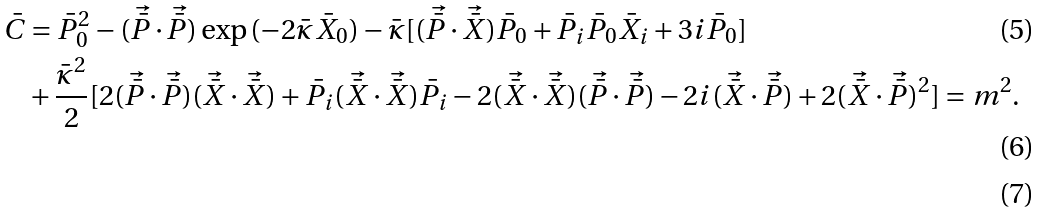Convert formula to latex. <formula><loc_0><loc_0><loc_500><loc_500>\bar { C } & = \bar { P } _ { 0 } ^ { 2 } - ( \vec { \bar { P } } \cdot \vec { \bar { P } } ) \exp { ( - 2 \bar { \kappa } \bar { X } _ { 0 } ) } - \bar { \kappa } [ ( \vec { \bar { P } } \cdot \vec { \bar { X } } ) \bar { P } _ { 0 } + \bar { P } _ { i } \bar { P } _ { 0 } \bar { X } _ { i } + 3 i \bar { P } _ { 0 } ] \\ & + \frac { \bar { \kappa } ^ { 2 } } { 2 } [ 2 ( \vec { \bar { P } } \cdot \vec { \bar { P } } ) ( \vec { \bar { X } } \cdot \vec { \bar { X } } ) + \bar { P } _ { i } ( \vec { \bar { X } } \cdot \vec { \bar { X } } ) \bar { P } _ { i } - 2 ( \vec { \bar { X } } \cdot \vec { \bar { X } } ) ( \vec { \bar { P } } \cdot \vec { \bar { P } } ) - 2 i ( \vec { \bar { X } } \cdot \vec { \bar { P } } ) + 2 ( \vec { \bar { X } } \cdot \vec { \bar { P } } ) ^ { 2 } ] = m ^ { 2 } . \\</formula> 